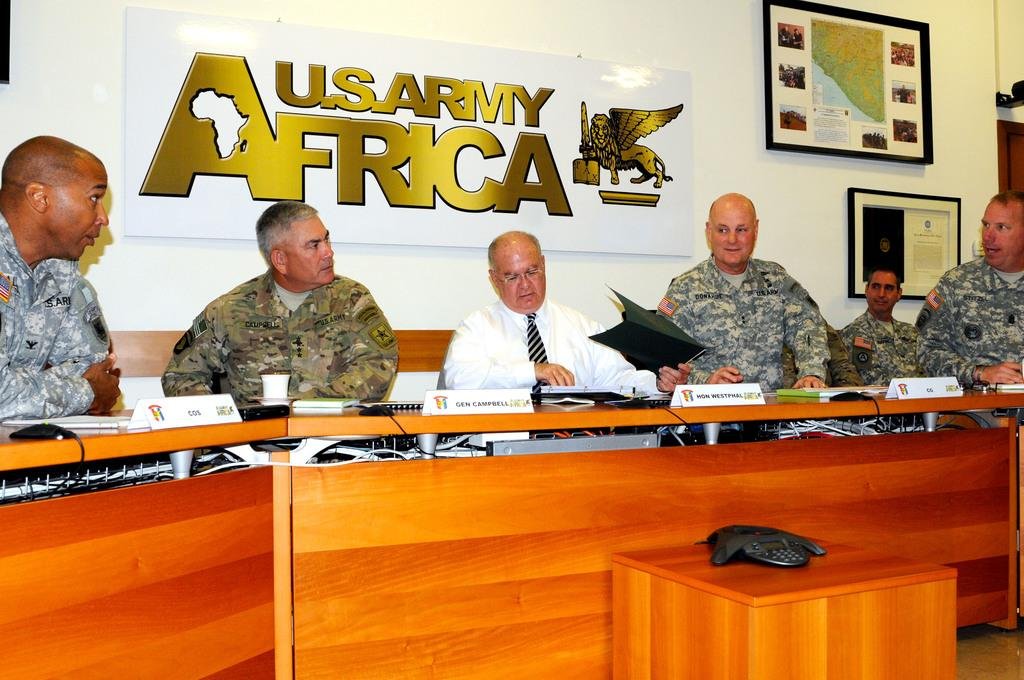How many people are in the image? There is a group of people in the image, but the exact number is not specified. What are the people doing in the image? The people are sitting in chairs in the image. What is in front of the people? There is a table in front of the people. What is on the board in the image? The board has "US Army Africa" written on it. What type of design can be seen on the juice in the image? There is no juice present in the image, so it is not possible to determine the design on any juice. 